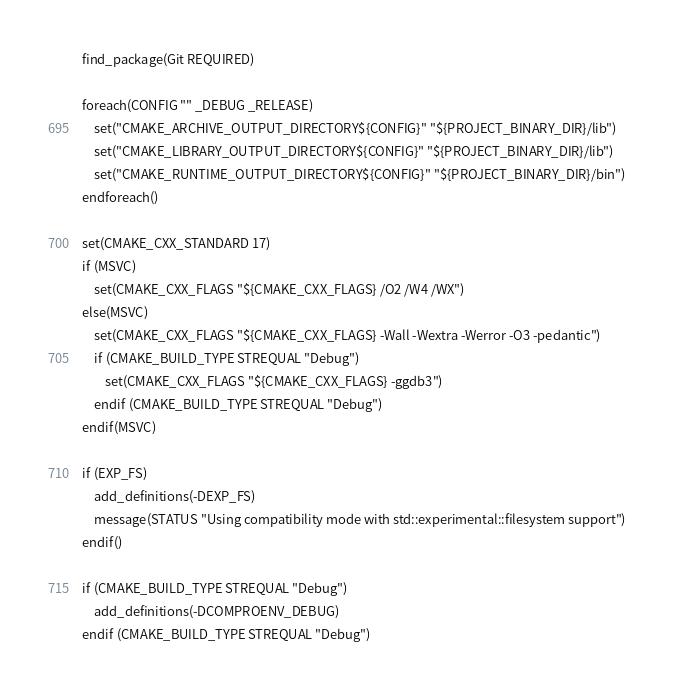<code> <loc_0><loc_0><loc_500><loc_500><_CMake_>find_package(Git REQUIRED)

foreach(CONFIG "" _DEBUG _RELEASE)
    set("CMAKE_ARCHIVE_OUTPUT_DIRECTORY${CONFIG}" "${PROJECT_BINARY_DIR}/lib")
    set("CMAKE_LIBRARY_OUTPUT_DIRECTORY${CONFIG}" "${PROJECT_BINARY_DIR}/lib")
    set("CMAKE_RUNTIME_OUTPUT_DIRECTORY${CONFIG}" "${PROJECT_BINARY_DIR}/bin")
endforeach()

set(CMAKE_CXX_STANDARD 17)
if (MSVC)
    set(CMAKE_CXX_FLAGS "${CMAKE_CXX_FLAGS} /O2 /W4 /WX")
else(MSVC)
    set(CMAKE_CXX_FLAGS "${CMAKE_CXX_FLAGS} -Wall -Wextra -Werror -O3 -pedantic")
    if (CMAKE_BUILD_TYPE STREQUAL "Debug")
        set(CMAKE_CXX_FLAGS "${CMAKE_CXX_FLAGS} -ggdb3")
    endif (CMAKE_BUILD_TYPE STREQUAL "Debug")
endif(MSVC)

if (EXP_FS)
    add_definitions(-DEXP_FS)
    message(STATUS "Using compatibility mode with std::experimental::filesystem support")
endif()

if (CMAKE_BUILD_TYPE STREQUAL "Debug")
    add_definitions(-DCOMPROENV_DEBUG)
endif (CMAKE_BUILD_TYPE STREQUAL "Debug")
</code> 